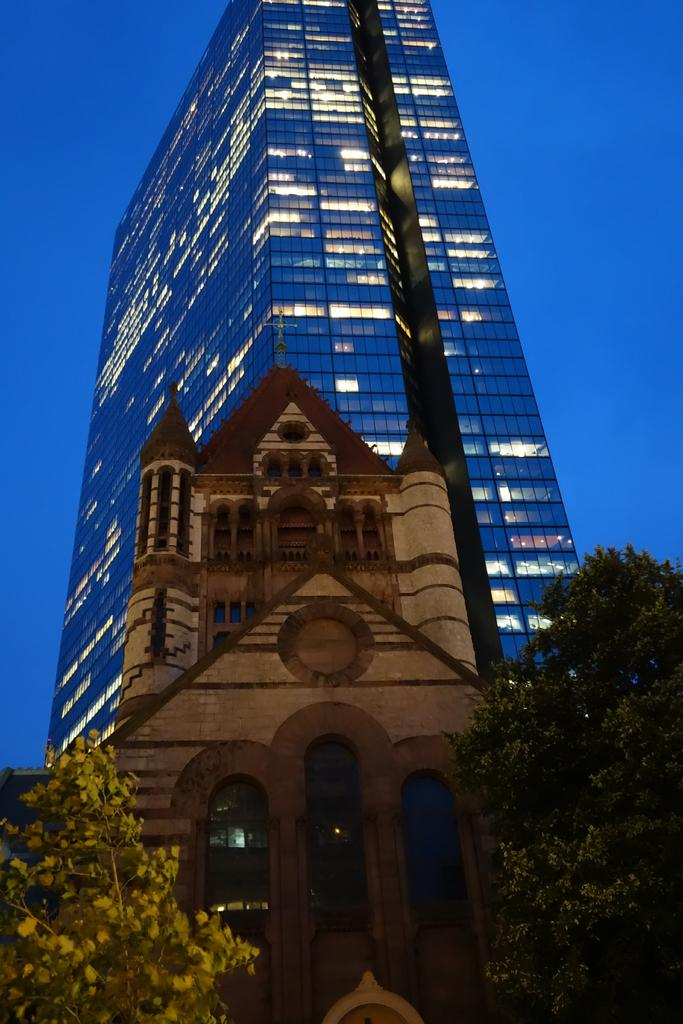What type of building can be seen in the image? There is a building in the image that resembles a church. What other structures can be seen in the background? There is a glass building visible in the background. What type of vegetation is present in the image? Plants are present in the image. What is visible in the sky in the image? The sky is visible in the image. What type of coil is used to create the holiday scene in the image? There is no coil or holiday scene present in the image. 